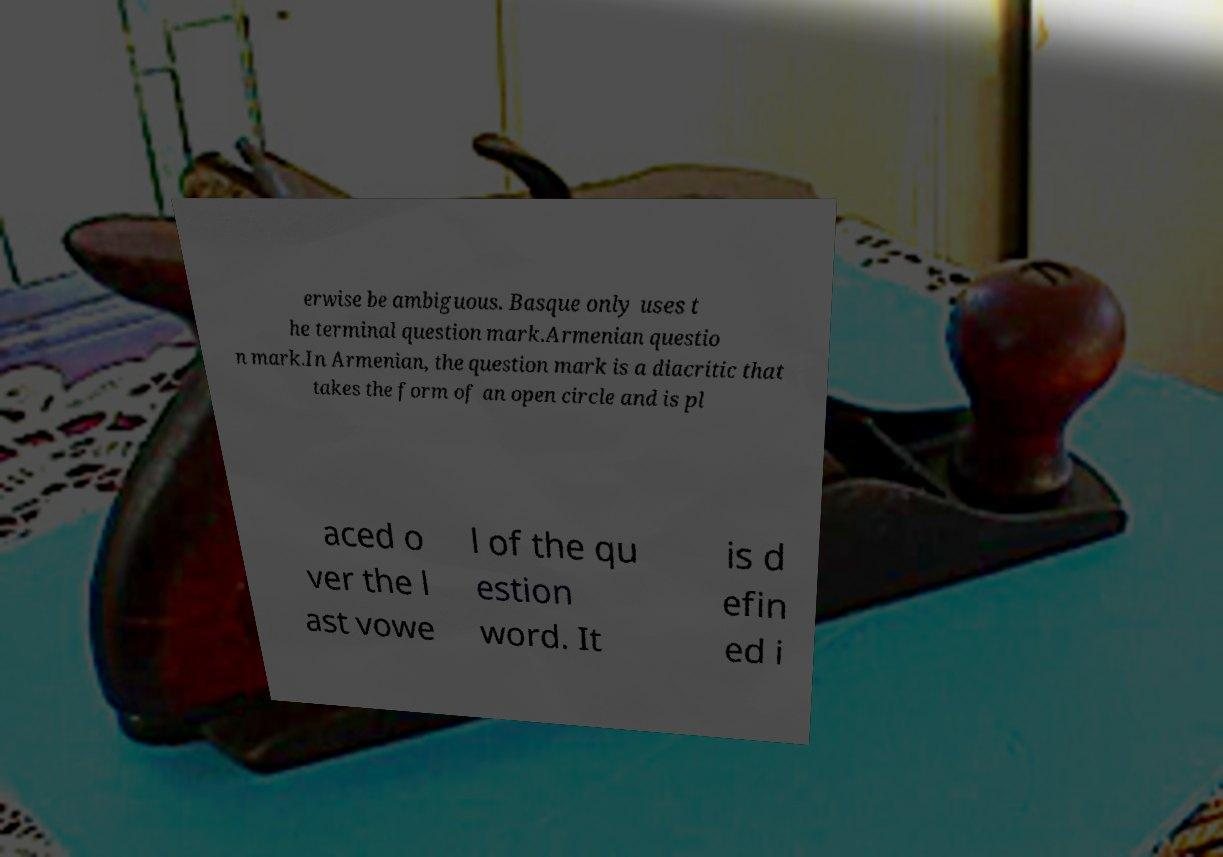Can you accurately transcribe the text from the provided image for me? erwise be ambiguous. Basque only uses t he terminal question mark.Armenian questio n mark.In Armenian, the question mark is a diacritic that takes the form of an open circle and is pl aced o ver the l ast vowe l of the qu estion word. It is d efin ed i 